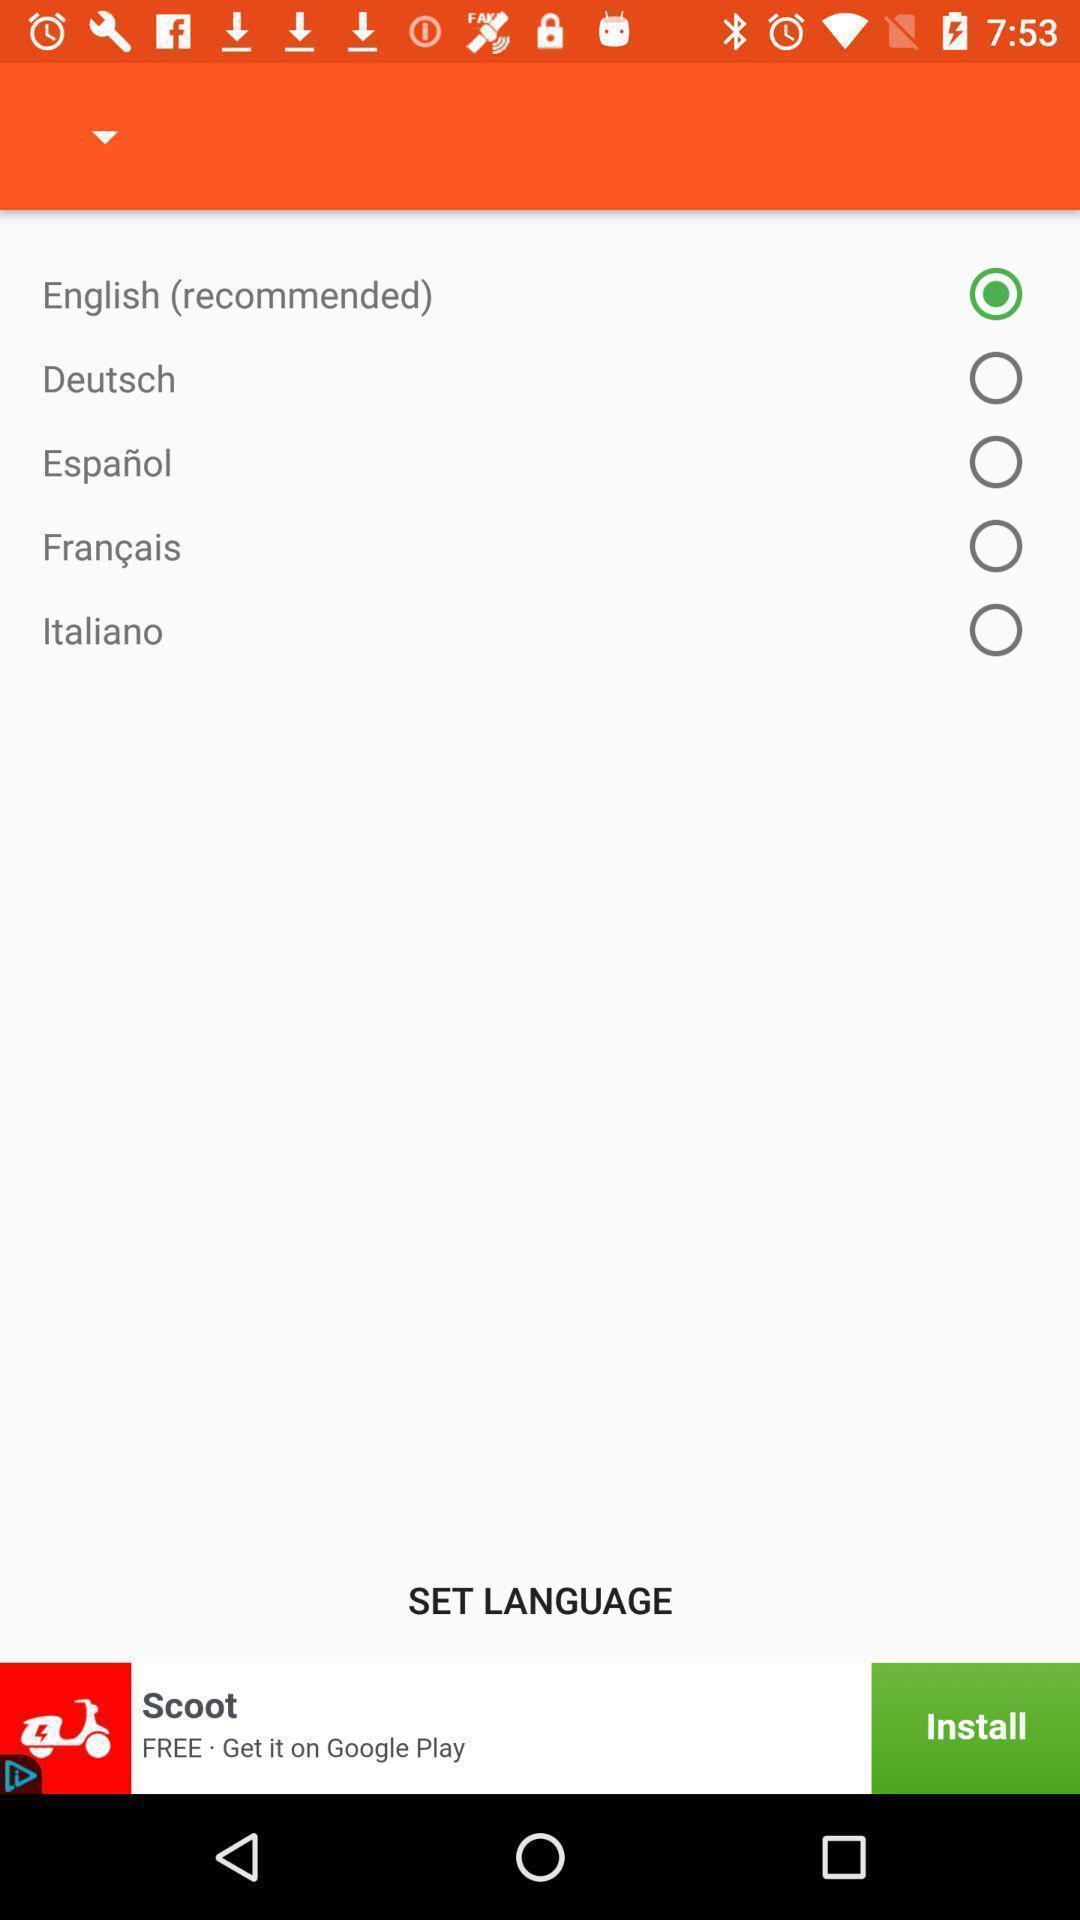What can you discern from this picture? Page displaying various languages. 